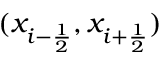<formula> <loc_0><loc_0><loc_500><loc_500>( x _ { i - \frac { 1 } { 2 } } , x _ { i + \frac { 1 } { 2 } } )</formula> 